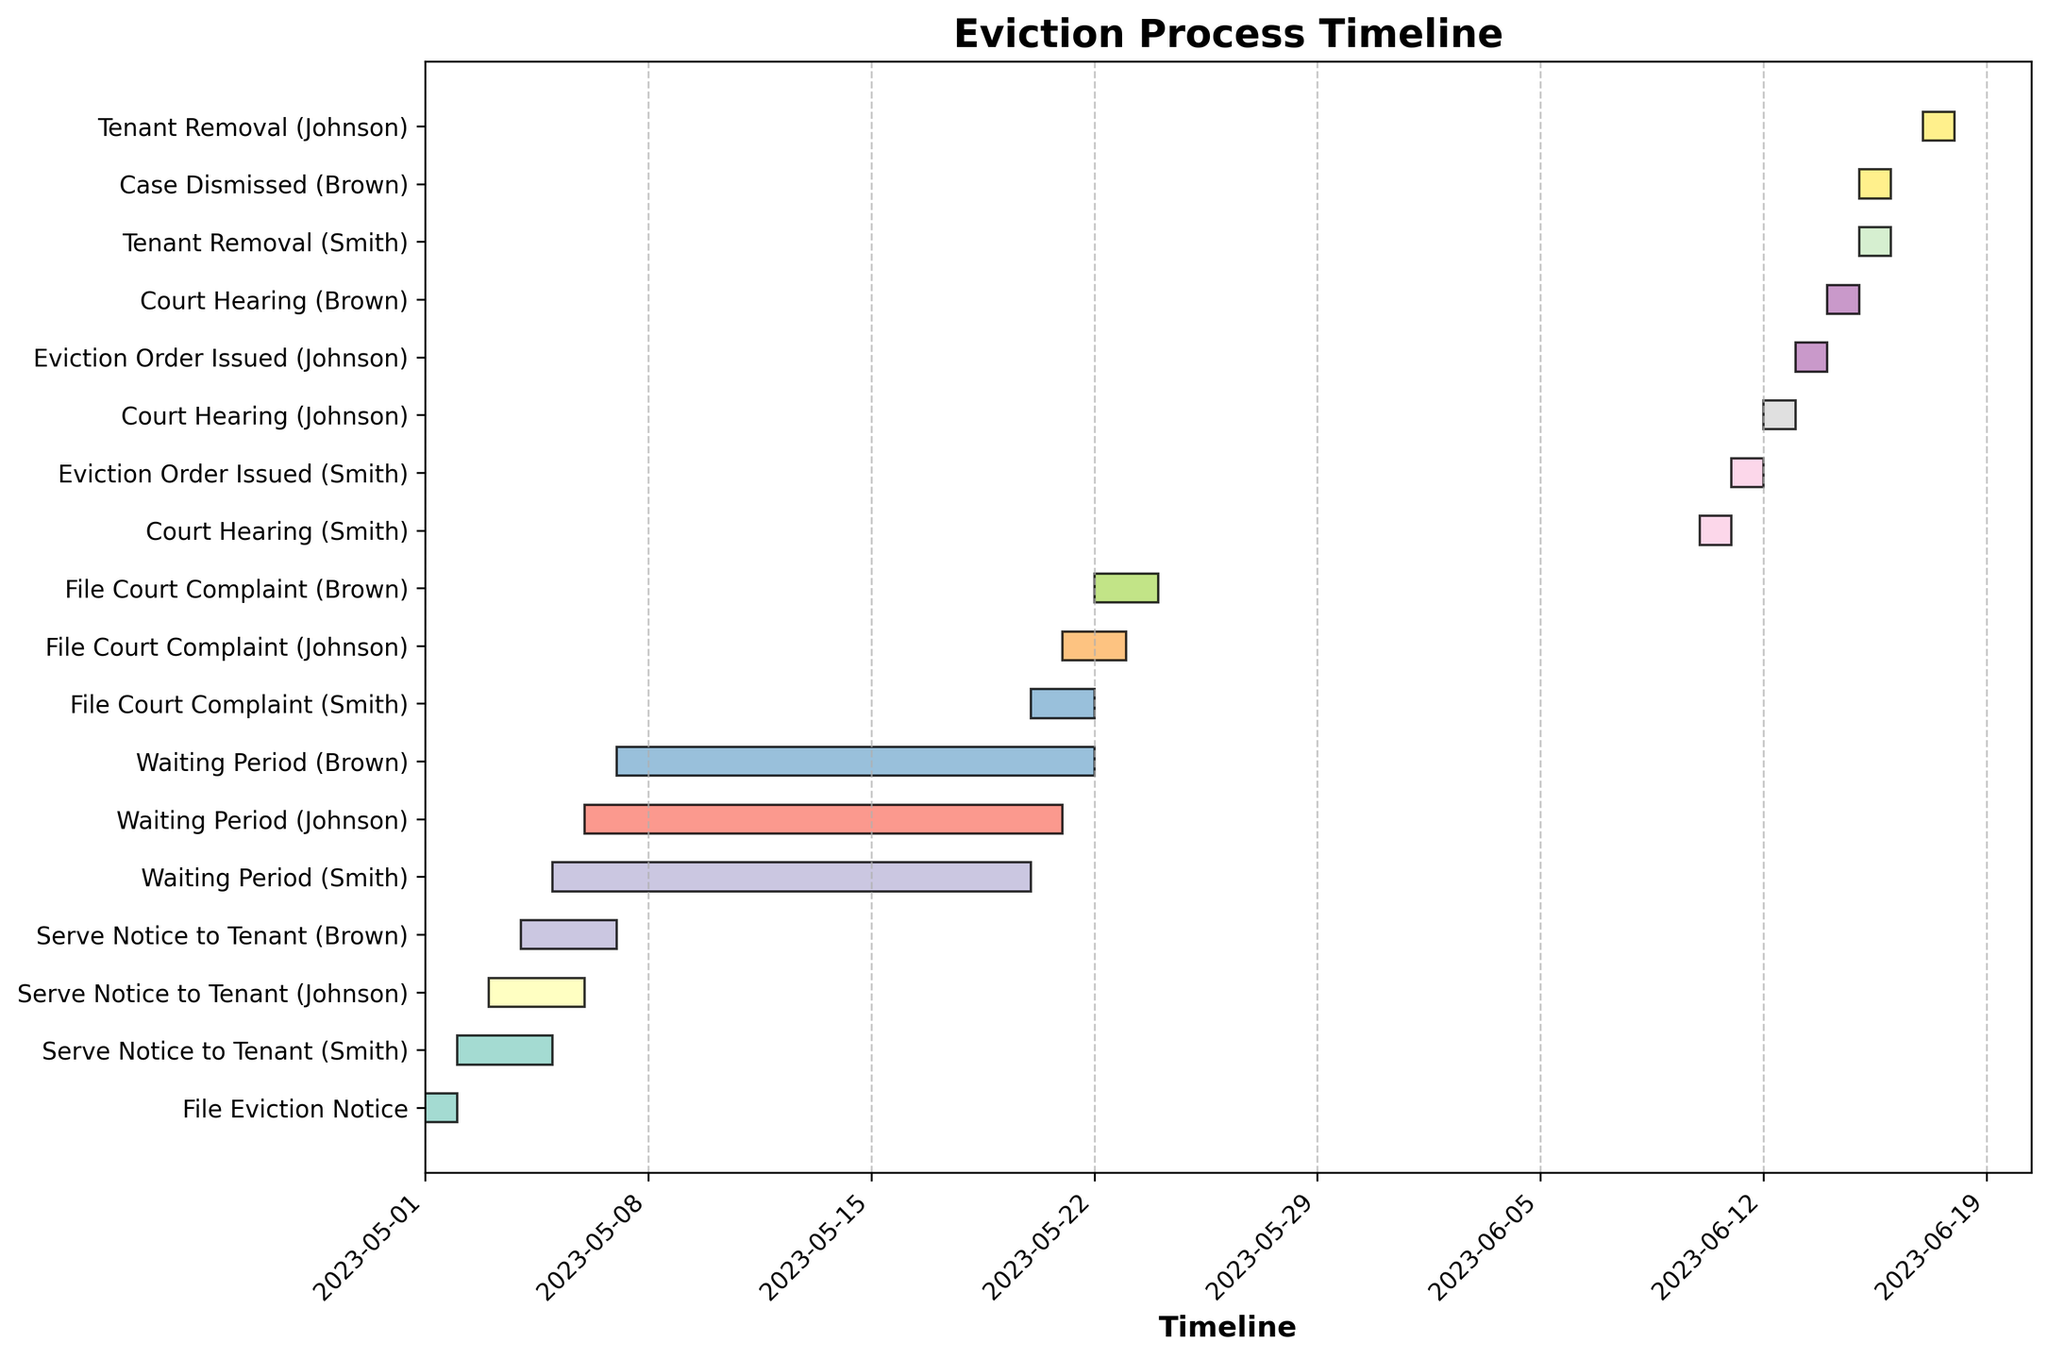When does the "Eviction Order Issued (Smith)" stage start? Locate the stage "Eviction Order Issued (Smith)" on the y-axis, then find the corresponding start date on the x-axis.
Answer: 2023-06-11 Which tenant had the Court Hearing stage first? Compare the start dates of the "Court Hearing" stage for Smith, Johnson, and Brown. The tenant with the earliest start date had the first hearing.
Answer: Smith Are there any stages that overlap in time between different tenants? Examine the Gantt Chart to see if any bars (representing stages) for different tenants start before a previous bar ends. Cross-check the start and end dates visually.
Answer: Yes, some stages overlap, like "Serve Notice to Tenant." What is the average duration of the "File Court Complaint" stage across all tenants? Calculate the duration in days for the "File Court Complaint" stage for Smith, Johnson, and Brown. Sum these durations and divide by the number of tenants to find the average. (Smith: 2 days, Johnson: 2 days, Brown: 2 days). (2 + 2 + 2)/3 = 2 days
Answer: 2 days How many unique stages are there in the eviction process for all tenants combined? Count the distinct stage names on the y-axis. Ensure no duplication by considering names only and ignoring the tenant-specific suffixes.
Answer: 7 unique stages Which tenant's eviction process concluded latest and when? Compare the end dates of the final stage for each tenant. The tenant with the latest end date has the latest conclusion for the eviction process.
Answer: Johnson, 2023-06-18 How many days was Brown's "Case Dismissed" stage? Find the "Case Dismissed (Brown)" stage on the y-axis and then determine its duration in days by examining the start and end dates.
Answer: 1 day 